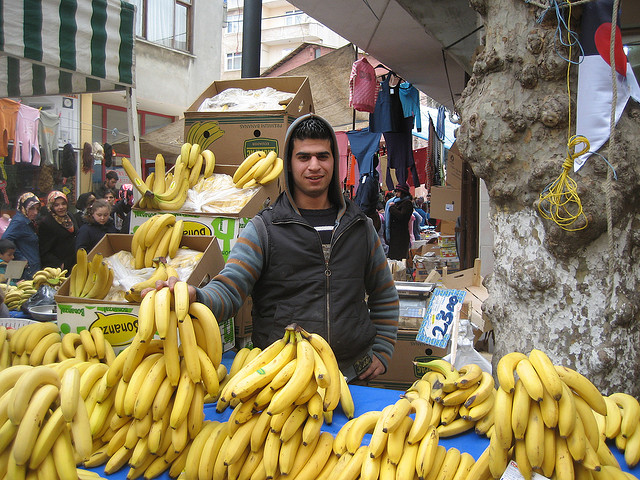Can you tell me what this person is selling? The person in the image is a vendor selling bananas at a market stall. What can you infer about the location of this market? Based on the clothing style and overall setting, it appears to be an open market possibly situated in a region where bananas are a popular commodity, likely a moderate to warm climate area. 